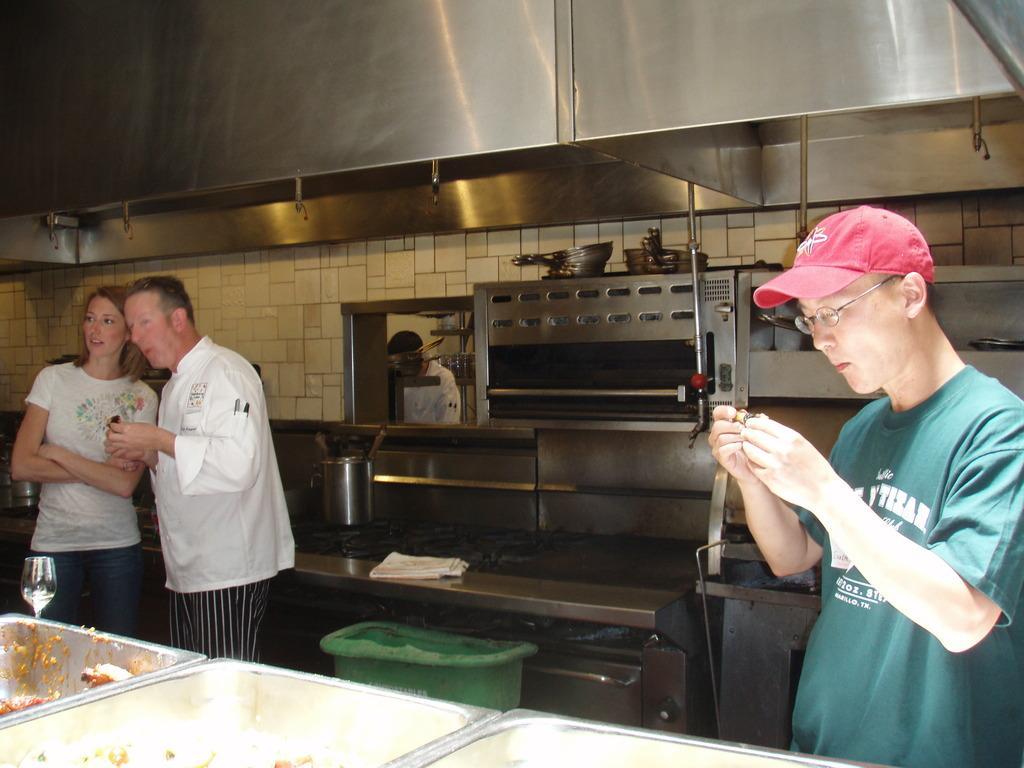In one or two sentences, can you explain what this image depicts? This image is taken in the kitchen. In this image we can see the vessels with food items. On the left there is a man and a woman standing. On the right there is a person holding an object and wearing the cap. In the background, we can see the kitchen counter top, a hand towel, green color bin and also some objects. We can also see the person. At the top we can see the steel rack. 